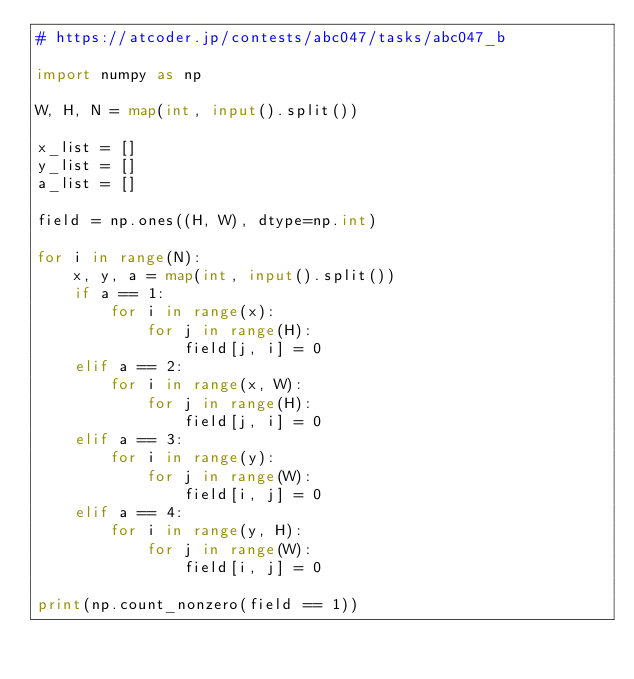<code> <loc_0><loc_0><loc_500><loc_500><_Python_># https://atcoder.jp/contests/abc047/tasks/abc047_b

import numpy as np

W, H, N = map(int, input().split())

x_list = []
y_list = []
a_list = []

field = np.ones((H, W), dtype=np.int)

for i in range(N):
    x, y, a = map(int, input().split())
    if a == 1:
        for i in range(x):
            for j in range(H):
                field[j, i] = 0
    elif a == 2:
        for i in range(x, W):
            for j in range(H):
                field[j, i] = 0
    elif a == 3:
        for i in range(y):
            for j in range(W):
                field[i, j] = 0
    elif a == 4:
        for i in range(y, H):
            for j in range(W):
                field[i, j] = 0

print(np.count_nonzero(field == 1))
    



</code> 